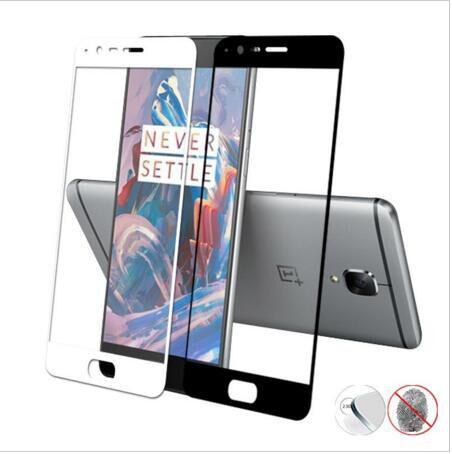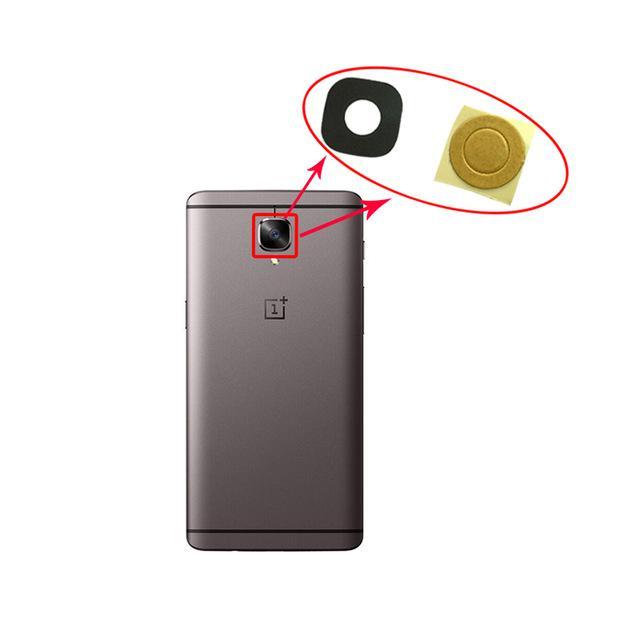The first image is the image on the left, the second image is the image on the right. For the images displayed, is the sentence "There is a total of three cell phones." factually correct? Answer yes or no. Yes. The first image is the image on the left, the second image is the image on the right. Examine the images to the left and right. Is the description "The back of a phone is visible." accurate? Answer yes or no. Yes. 